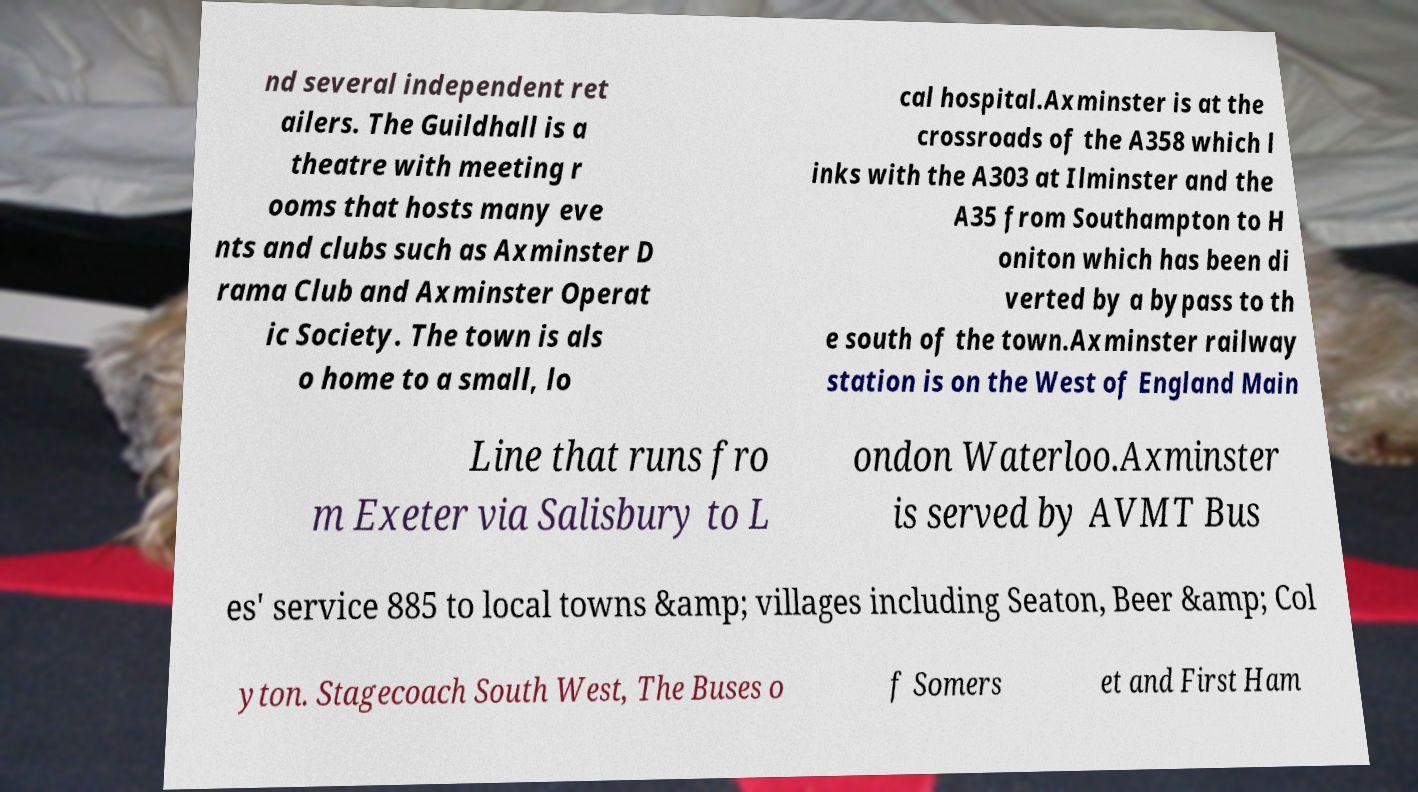Can you read and provide the text displayed in the image?This photo seems to have some interesting text. Can you extract and type it out for me? nd several independent ret ailers. The Guildhall is a theatre with meeting r ooms that hosts many eve nts and clubs such as Axminster D rama Club and Axminster Operat ic Society. The town is als o home to a small, lo cal hospital.Axminster is at the crossroads of the A358 which l inks with the A303 at Ilminster and the A35 from Southampton to H oniton which has been di verted by a bypass to th e south of the town.Axminster railway station is on the West of England Main Line that runs fro m Exeter via Salisbury to L ondon Waterloo.Axminster is served by AVMT Bus es' service 885 to local towns &amp; villages including Seaton, Beer &amp; Col yton. Stagecoach South West, The Buses o f Somers et and First Ham 